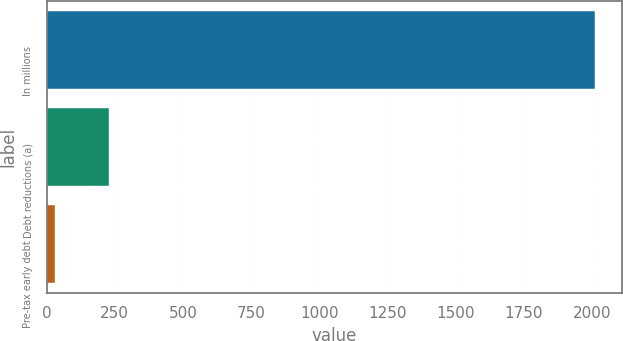Convert chart to OTSL. <chart><loc_0><loc_0><loc_500><loc_500><bar_chart><fcel>In millions<fcel>Debt reductions (a)<fcel>Pre-tax early debt<nl><fcel>2011<fcel>229.9<fcel>32<nl></chart> 